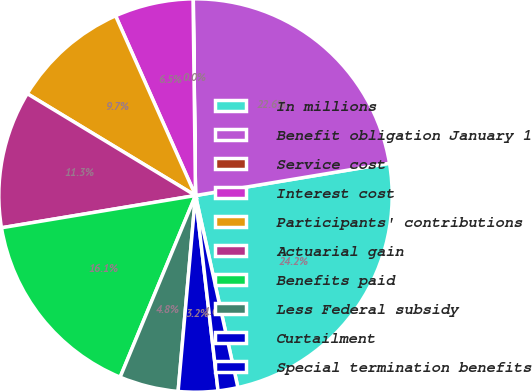Convert chart. <chart><loc_0><loc_0><loc_500><loc_500><pie_chart><fcel>In millions<fcel>Benefit obligation January 1<fcel>Service cost<fcel>Interest cost<fcel>Participants' contributions<fcel>Actuarial gain<fcel>Benefits paid<fcel>Less Federal subsidy<fcel>Curtailment<fcel>Special termination benefits<nl><fcel>24.17%<fcel>22.56%<fcel>0.02%<fcel>6.46%<fcel>9.68%<fcel>11.29%<fcel>16.12%<fcel>4.85%<fcel>3.24%<fcel>1.63%<nl></chart> 